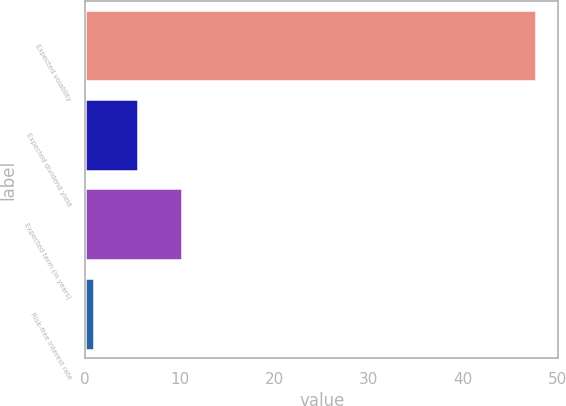Convert chart. <chart><loc_0><loc_0><loc_500><loc_500><bar_chart><fcel>Expected volatility<fcel>Expected dividend yield<fcel>Expected term (in years)<fcel>Risk-free interest rate<nl><fcel>47.7<fcel>5.6<fcel>10.28<fcel>0.92<nl></chart> 